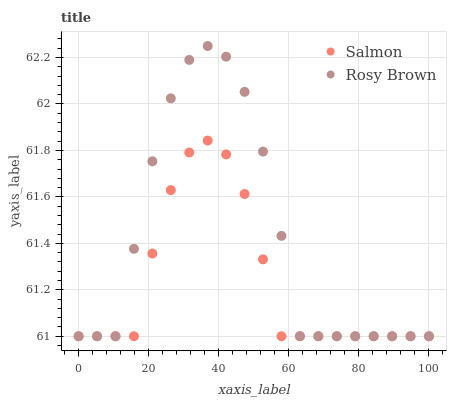Does Salmon have the minimum area under the curve?
Answer yes or no. Yes. Does Rosy Brown have the maximum area under the curve?
Answer yes or no. Yes. Does Salmon have the maximum area under the curve?
Answer yes or no. No. Is Salmon the smoothest?
Answer yes or no. Yes. Is Rosy Brown the roughest?
Answer yes or no. Yes. Is Salmon the roughest?
Answer yes or no. No. Does Rosy Brown have the lowest value?
Answer yes or no. Yes. Does Rosy Brown have the highest value?
Answer yes or no. Yes. Does Salmon have the highest value?
Answer yes or no. No. Does Salmon intersect Rosy Brown?
Answer yes or no. Yes. Is Salmon less than Rosy Brown?
Answer yes or no. No. Is Salmon greater than Rosy Brown?
Answer yes or no. No. 